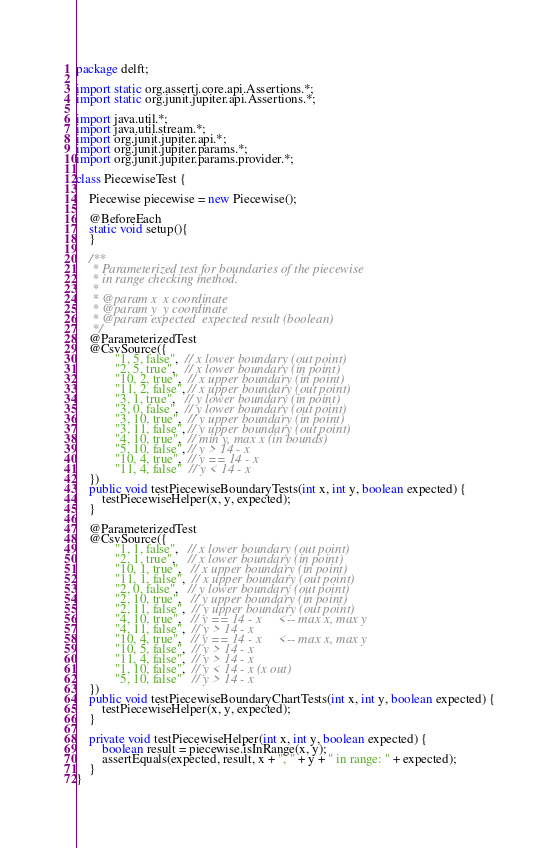Convert code to text. <code><loc_0><loc_0><loc_500><loc_500><_Java_>package delft;

import static org.assertj.core.api.Assertions.*;
import static org.junit.jupiter.api.Assertions.*;

import java.util.*;
import java.util.stream.*;
import org.junit.jupiter.api.*;
import org.junit.jupiter.params.*;
import org.junit.jupiter.params.provider.*;

class PiecewiseTest {

    Piecewise piecewise = new Piecewise();

    @BeforeEach
    static void setup(){
    }

    /**
     * Parameterized test for boundaries of the piecewise
     * in range checking method.
     *
     * @param x  x coordinate
     * @param y  y coordinate
     * @param expected  expected result (boolean)
     */
    @ParameterizedTest
    @CsvSource({
            "1, 5, false",  // x lower boundary (out point)
            "2, 5, true",   // x lower boundary (in point)
            "10, 2, true",  // x upper boundary (in point)
            "11, 2, false", // x upper boundary (out point)
            "3, 1, true",   // y lower boundary (in point)
            "3, 0, false",  // y lower boundary (out point)
            "3, 10, true",  // y upper boundary (in point)
            "3, 11, false", // y upper boundary (out point)
            "4, 10, true",  // min y, max x (in bounds)
            "5, 10, false", // y > 14 - x
            "10, 4, true",  // y == 14 - x
            "11, 4, false"  // y < 14 - x
    })
    public void testPiecewiseBoundaryTests(int x, int y, boolean expected) {
        testPiecewiseHelper(x, y, expected);
    }

    @ParameterizedTest
    @CsvSource({
            "1, 1, false",   // x lower boundary (out point)
            "2, 1, true",    // x lower boundary (in point)
            "10, 1, true",   // x upper boundary (in point)
            "11, 1, false",  // x upper boundary (out point)
            "2, 0, false",   // y lower boundary (out point)
            "2, 10, true",   // y upper boundary (in point)
            "2, 11, false",  // y upper boundary (out point)
            "4, 10, true",   // y == 14 - x     <-- max x, max y
            "4, 11, false",  // y > 14 - x
            "10, 4, true",   // y == 14 - x     <-- max x, max y
            "10, 5, false",  // y > 14 - x
            "11, 4, false",  // y > 14 - x
            "1, 10, false",  // y < 14 - x (x out)
            "5, 10, false"   // y > 14 - x
    })
    public void testPiecewiseBoundaryChartTests(int x, int y, boolean expected) {
        testPiecewiseHelper(x, y, expected);
    }

    private void testPiecewiseHelper(int x, int y, boolean expected) {
        boolean result = piecewise.isInRange(x, y);
        assertEquals(expected, result, x + ", " + y + " in range: " + expected);
    }
}</code> 